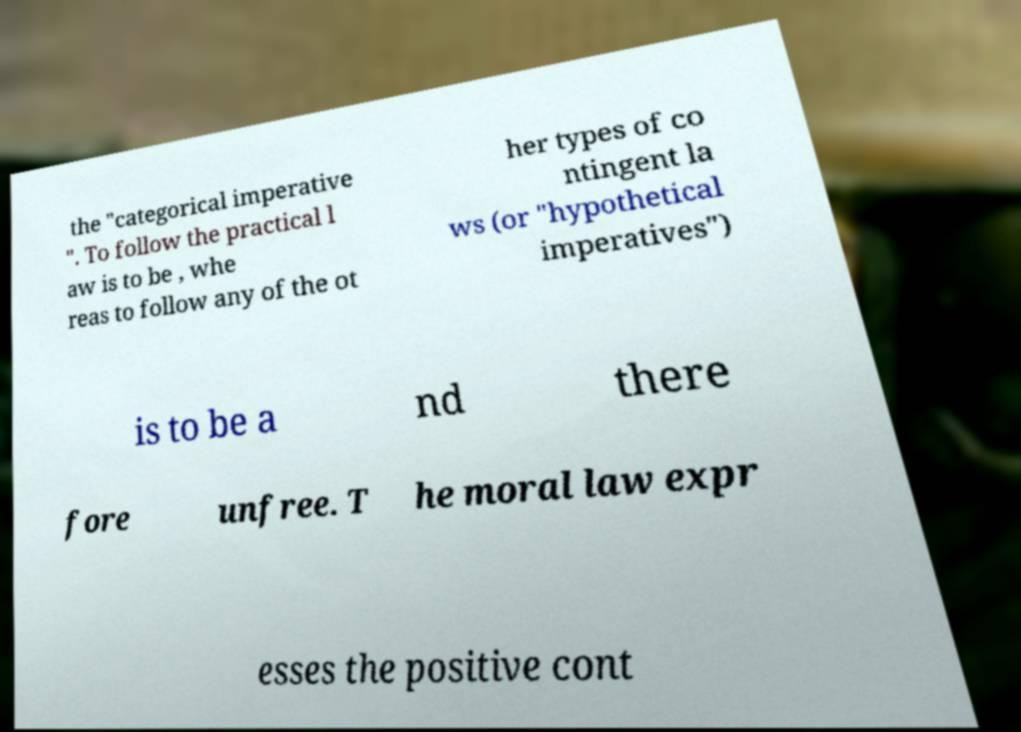Please identify and transcribe the text found in this image. the "categorical imperative ". To follow the practical l aw is to be , whe reas to follow any of the ot her types of co ntingent la ws (or "hypothetical imperatives") is to be a nd there fore unfree. T he moral law expr esses the positive cont 